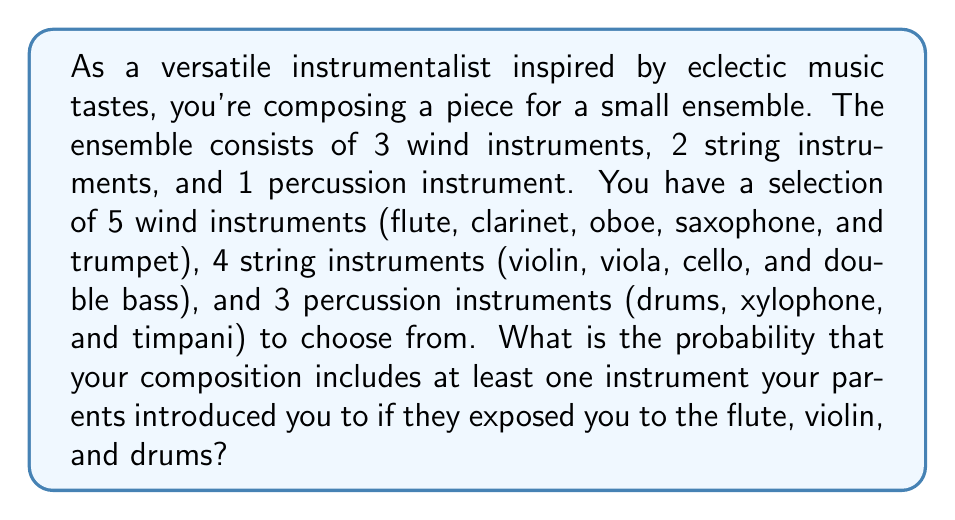Can you solve this math problem? Let's approach this step-by-step:

1) First, we need to calculate the total number of possible ensemble combinations:
   $${5 \choose 3} \cdot {4 \choose 2} \cdot {3 \choose 1} = 10 \cdot 6 \cdot 3 = 180$$

2) Now, let's calculate the probability of NOT including any of the instruments your parents introduced you to:
   
   a) Probability of not choosing flute from wind instruments:
      $$P(\text{no flute}) = \frac{{4 \choose 3}}{{5 \choose 3}} = \frac{4}{10}$$
   
   b) Probability of not choosing violin from string instruments:
      $$P(\text{no violin}) = \frac{{3 \choose 2}}{{4 \choose 2}} = \frac{3}{6} = \frac{1}{2}$$
   
   c) Probability of not choosing drums from percussion instruments:
      $$P(\text{no drums}) = \frac{{2 \choose 1}}{{3 \choose 1}} = \frac{2}{3}$$

3) The probability of not including any of these instruments is the product of these probabilities:
   $$P(\text{none}) = \frac{4}{10} \cdot \frac{1}{2} \cdot \frac{2}{3} = \frac{4}{30} = \frac{2}{15}$$

4) Therefore, the probability of including at least one of these instruments is:
   $$P(\text{at least one}) = 1 - P(\text{none}) = 1 - \frac{2}{15} = \frac{13}{15}$$
Answer: The probability that your composition includes at least one instrument your parents introduced you to is $\frac{13}{15}$ or approximately 0.8667 or 86.67%. 